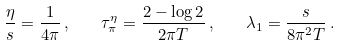<formula> <loc_0><loc_0><loc_500><loc_500>\frac { \eta } { s } = \frac { 1 } { 4 \pi } \, , \quad \tau _ { \pi } ^ { \eta } = \frac { 2 - \log 2 } { 2 \pi T } \, , \quad \lambda _ { 1 } = \frac { s } { 8 \pi ^ { 2 } T } \, .</formula> 